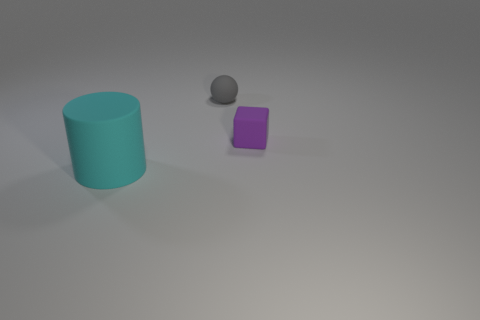The rubber object that is in front of the tiny purple cube has what shape?
Your response must be concise. Cylinder. Are the object that is to the left of the small gray matte ball and the tiny object that is right of the tiny gray rubber ball made of the same material?
Keep it short and to the point. Yes. What number of things are either purple blocks or small things to the right of the tiny gray matte object?
Offer a very short reply. 1. There is a thing that is in front of the rubber thing right of the gray matte object; what color is it?
Your answer should be very brief. Cyan. How many rubber things are large cyan objects or balls?
Ensure brevity in your answer.  2. Is the cyan cylinder made of the same material as the tiny gray ball?
Provide a short and direct response. Yes. There is a tiny thing that is to the left of the small object in front of the tiny matte ball; what is it made of?
Your answer should be very brief. Rubber. What number of big objects are either brown matte objects or cyan matte objects?
Your answer should be very brief. 1. How big is the matte cylinder?
Your response must be concise. Large. Is the number of balls that are on the left side of the small purple matte thing greater than the number of purple shiny blocks?
Ensure brevity in your answer.  Yes. 